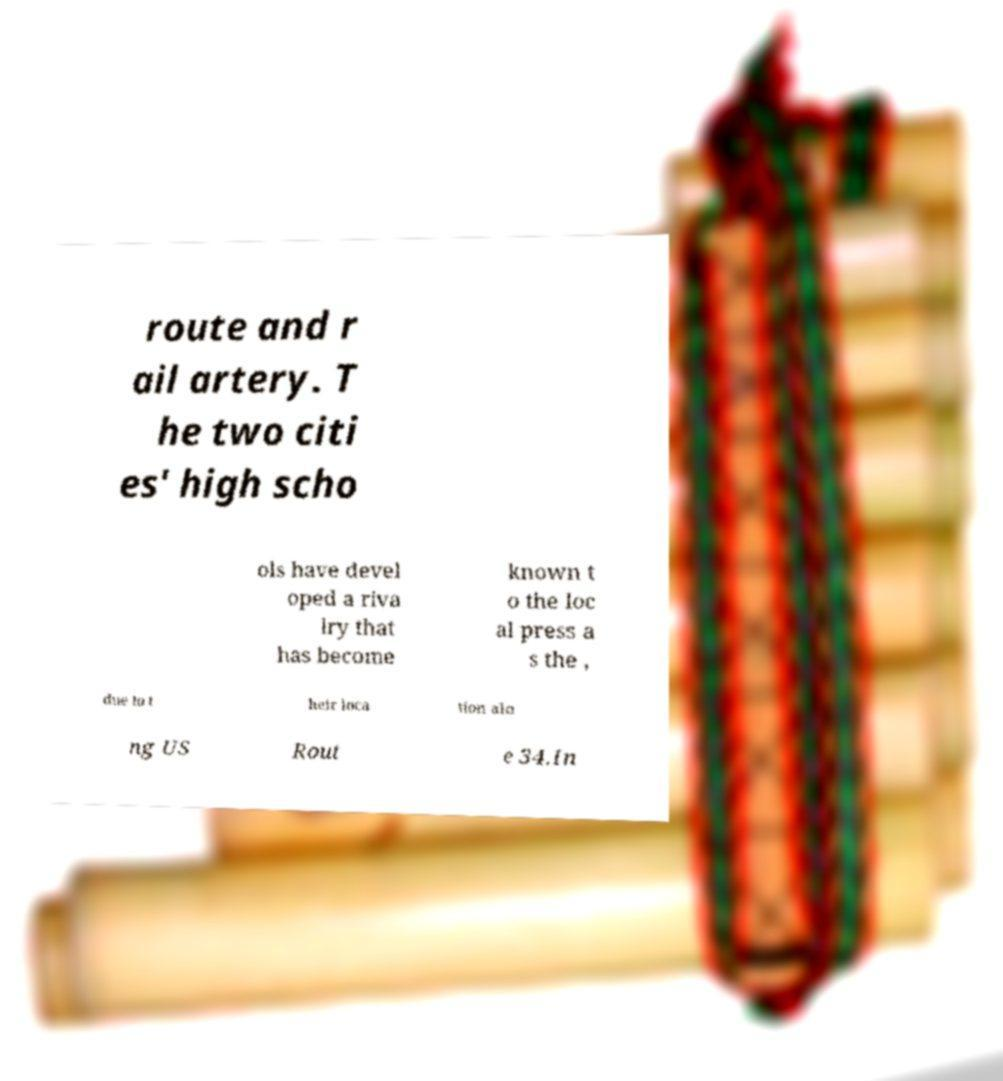Can you read and provide the text displayed in the image?This photo seems to have some interesting text. Can you extract and type it out for me? route and r ail artery. T he two citi es' high scho ols have devel oped a riva lry that has become known t o the loc al press a s the , due to t heir loca tion alo ng US Rout e 34.In 